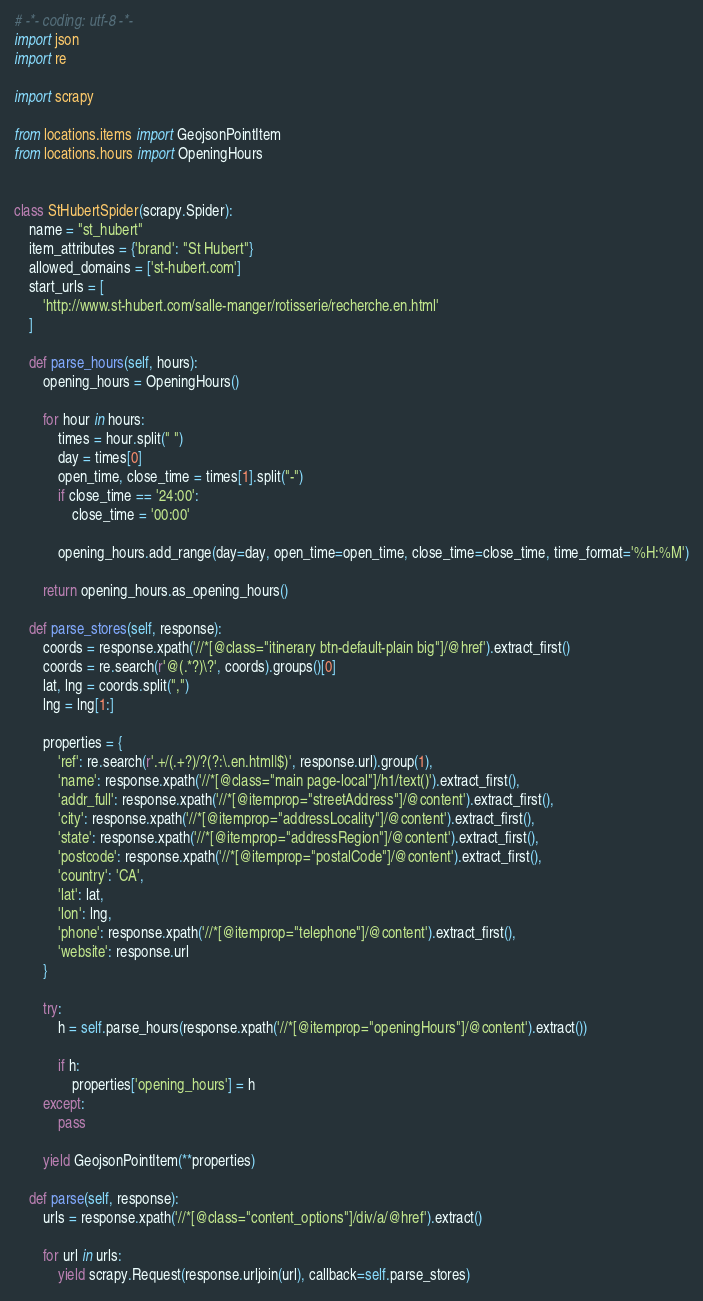<code> <loc_0><loc_0><loc_500><loc_500><_Python_># -*- coding: utf-8 -*-
import json
import re

import scrapy

from locations.items import GeojsonPointItem
from locations.hours import OpeningHours


class StHubertSpider(scrapy.Spider):
    name = "st_hubert"
    item_attributes = {'brand': "St Hubert"}
    allowed_domains = ['st-hubert.com']
    start_urls = [
        'http://www.st-hubert.com/salle-manger/rotisserie/recherche.en.html'
    ]

    def parse_hours(self, hours):
        opening_hours = OpeningHours()

        for hour in hours:
            times = hour.split(" ")
            day = times[0]
            open_time, close_time = times[1].split("-")
            if close_time == '24:00':
                close_time = '00:00'

            opening_hours.add_range(day=day, open_time=open_time, close_time=close_time, time_format='%H:%M')

        return opening_hours.as_opening_hours()

    def parse_stores(self, response):
        coords = response.xpath('//*[@class="itinerary btn-default-plain big"]/@href').extract_first()
        coords = re.search(r'@(.*?)\?', coords).groups()[0]
        lat, lng = coords.split(",")
        lng = lng[1:]

        properties = {
            'ref': re.search(r'.+/(.+?)/?(?:\.en.html|$)', response.url).group(1),
            'name': response.xpath('//*[@class="main page-local"]/h1/text()').extract_first(),
            'addr_full': response.xpath('//*[@itemprop="streetAddress"]/@content').extract_first(),
            'city': response.xpath('//*[@itemprop="addressLocality"]/@content').extract_first(),
            'state': response.xpath('//*[@itemprop="addressRegion"]/@content').extract_first(),
            'postcode': response.xpath('//*[@itemprop="postalCode"]/@content').extract_first(),
            'country': 'CA',
            'lat': lat,
            'lon': lng,
            'phone': response.xpath('//*[@itemprop="telephone"]/@content').extract_first(),
            'website': response.url
        }

        try:
            h = self.parse_hours(response.xpath('//*[@itemprop="openingHours"]/@content').extract())

            if h:
                properties['opening_hours'] = h
        except:
            pass

        yield GeojsonPointItem(**properties)

    def parse(self, response):
        urls = response.xpath('//*[@class="content_options"]/div/a/@href').extract()

        for url in urls:
            yield scrapy.Request(response.urljoin(url), callback=self.parse_stores)
</code> 